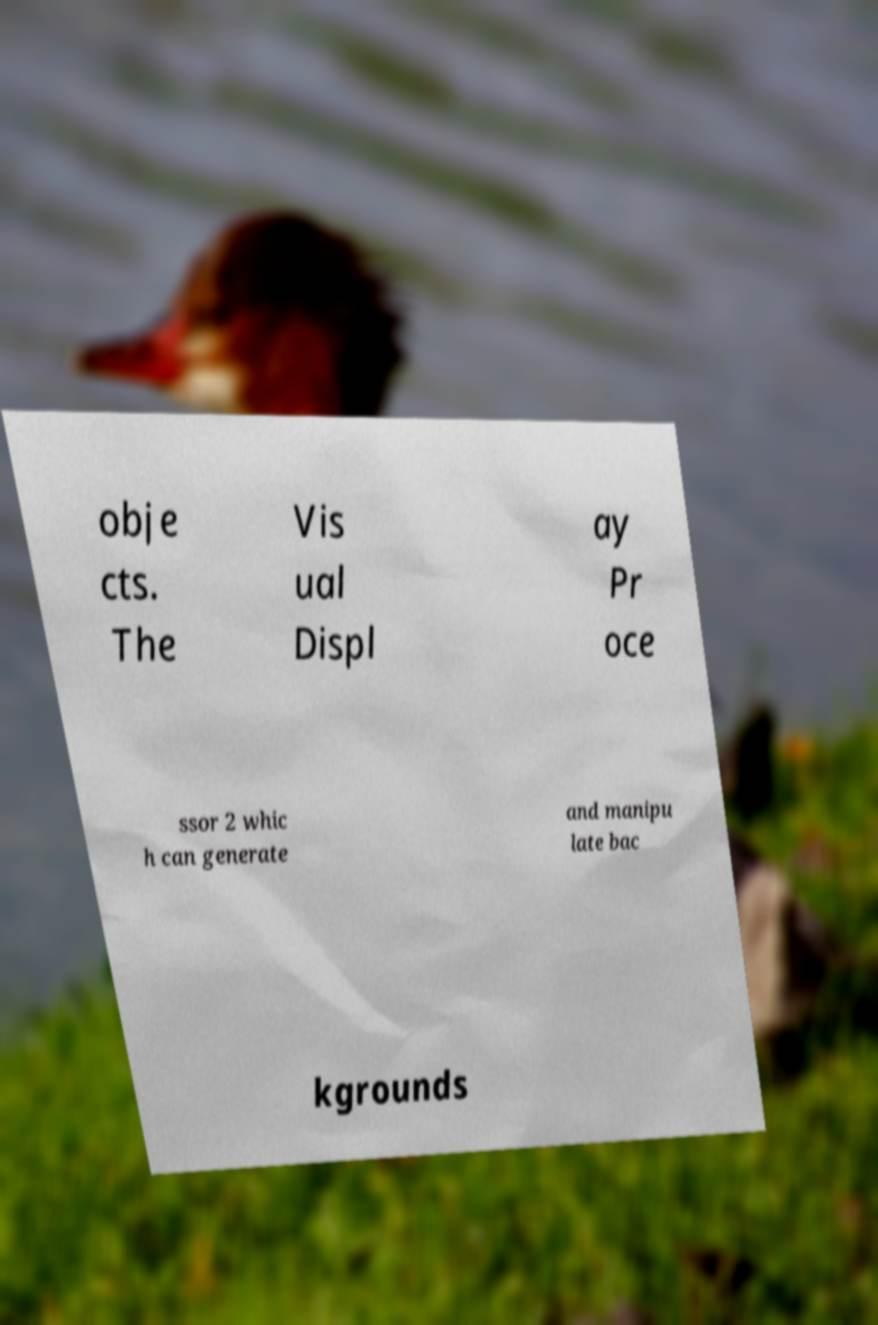Can you read and provide the text displayed in the image?This photo seems to have some interesting text. Can you extract and type it out for me? obje cts. The Vis ual Displ ay Pr oce ssor 2 whic h can generate and manipu late bac kgrounds 